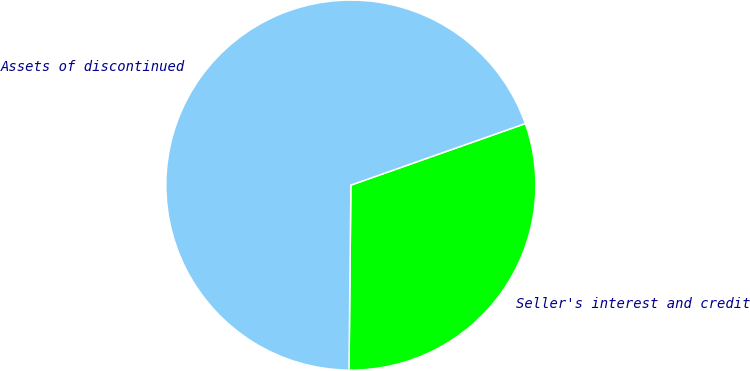<chart> <loc_0><loc_0><loc_500><loc_500><pie_chart><fcel>Seller's interest and credit<fcel>Assets of discontinued<nl><fcel>30.56%<fcel>69.44%<nl></chart> 